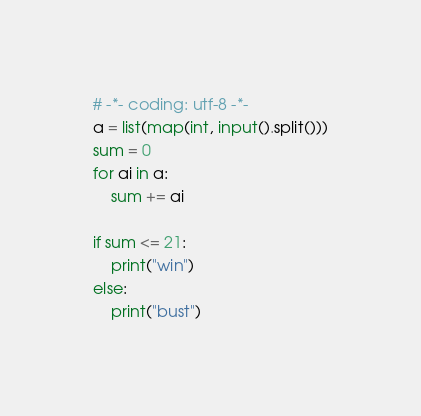<code> <loc_0><loc_0><loc_500><loc_500><_Python_># -*- coding: utf-8 -*-
a = list(map(int, input().split()))
sum = 0
for ai in a:
    sum += ai

if sum <= 21:
    print("win")
else:
    print("bust")

</code> 